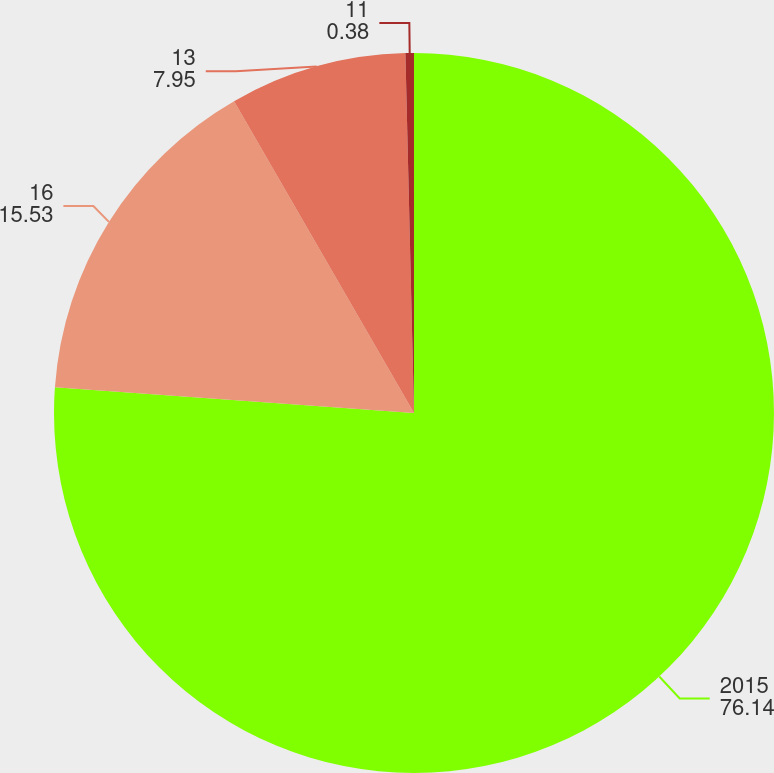Convert chart to OTSL. <chart><loc_0><loc_0><loc_500><loc_500><pie_chart><fcel>2015<fcel>16<fcel>13<fcel>11<nl><fcel>76.14%<fcel>15.53%<fcel>7.95%<fcel>0.38%<nl></chart> 